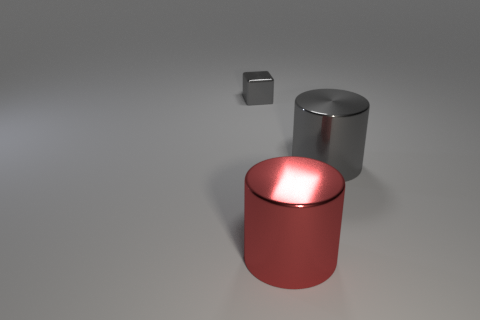Is there anything significant about the positioning of the objects? The objects are positioned in a way to create a sense of depth and perspective, with the smaller gray cube seemingly floating, and the larger cylindrical shapes in the foreground and background, which may indicate an artistic or conceptual intention behind their placement. 